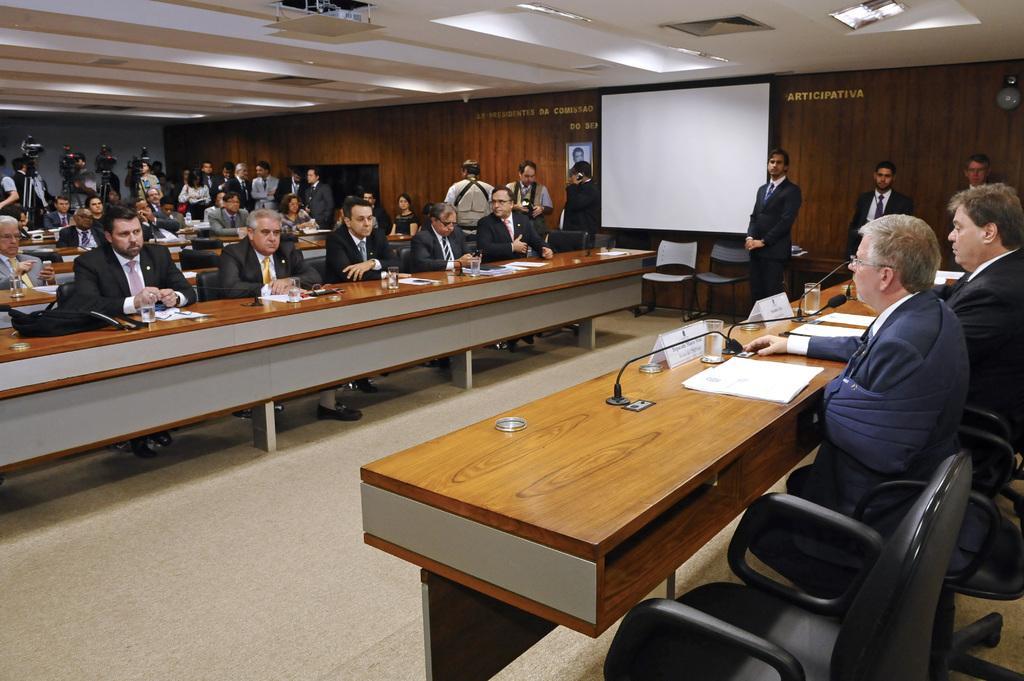In one or two sentences, can you explain what this image depicts? In this picture we can see group of people where some are sitting on chairs and some are standing at back side with cameras and in front of them on table we can see glasses, papers, name boards and beside to them we have wall, screen, frame. 